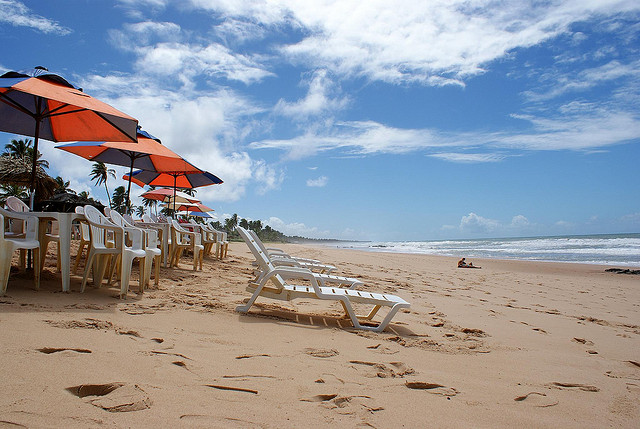What type of trees are in this picture?
Answer the question using a single word or phrase. Palm 